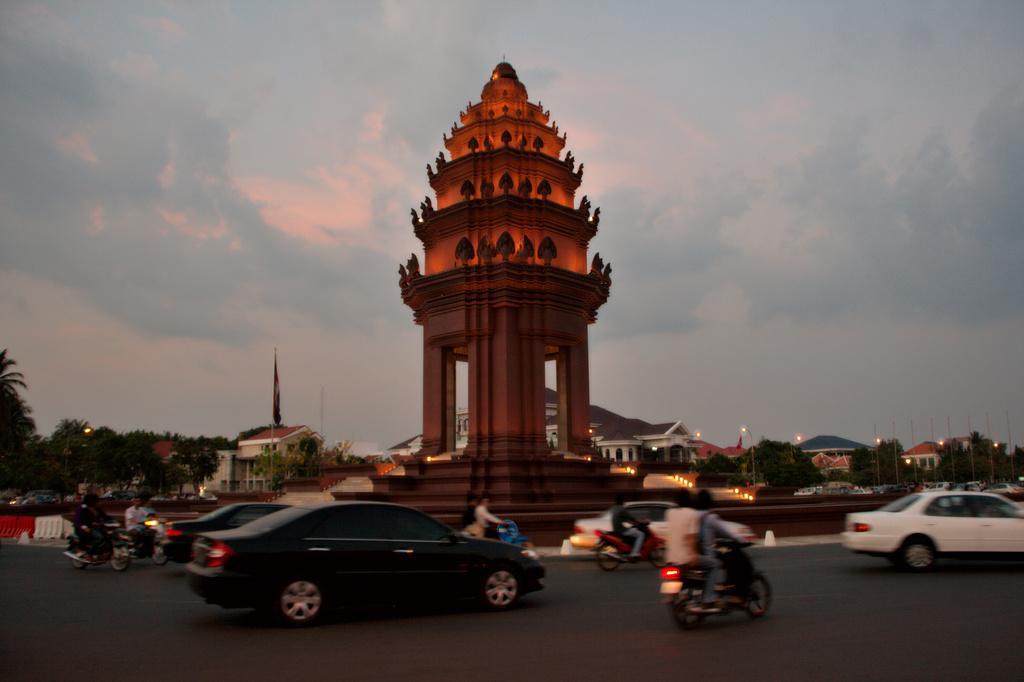Could you give a brief overview of what you see in this image? In this image we can see vehicles moving on the road, we can see an architecture, lights, flags, houses, trees and the sky with clouds in the background. 